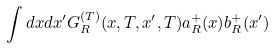Convert formula to latex. <formula><loc_0><loc_0><loc_500><loc_500>\int d x d x ^ { \prime } G _ { R } ^ { ( T ) } ( x , T , x ^ { \prime } , T ) a _ { R } ^ { + } ( x ) b _ { R } ^ { + } ( x ^ { \prime } )</formula> 